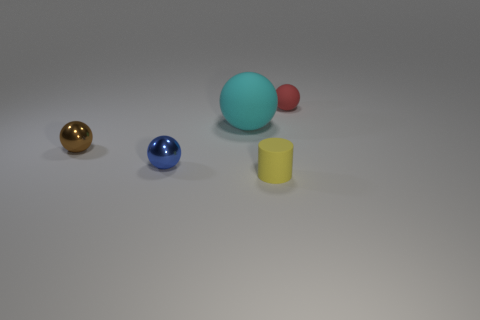Add 2 red spheres. How many objects exist? 7 Subtract all cylinders. How many objects are left? 4 Subtract all large cyan rubber balls. Subtract all cyan spheres. How many objects are left? 3 Add 1 blue shiny objects. How many blue shiny objects are left? 2 Add 4 big matte balls. How many big matte balls exist? 5 Subtract 1 red spheres. How many objects are left? 4 